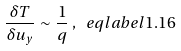<formula> <loc_0><loc_0><loc_500><loc_500>\frac { \delta T } { \delta u _ { y } } \sim \frac { 1 } { q } \, , \ e q l a b e l { 1 . 1 6 }</formula> 